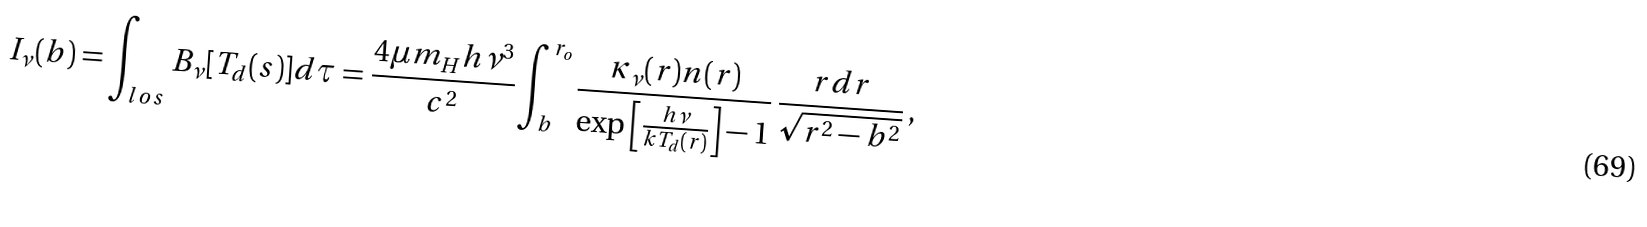Convert formula to latex. <formula><loc_0><loc_0><loc_500><loc_500>I _ { \nu } ( b ) = \int _ { l o s } B _ { \nu } [ T _ { d } ( s ) ] d \tau = \frac { 4 \mu m _ { H } h \nu ^ { 3 } } { c ^ { 2 } } \int _ { b } ^ { r _ { o } } \frac { \kappa _ { \nu } ( r ) n ( r ) } { \exp \left [ \frac { h \nu } { k T _ { d } ( r ) } \right ] - 1 } \, \frac { r d r } { \sqrt { r ^ { 2 } - b ^ { 2 } } } \, ,</formula> 